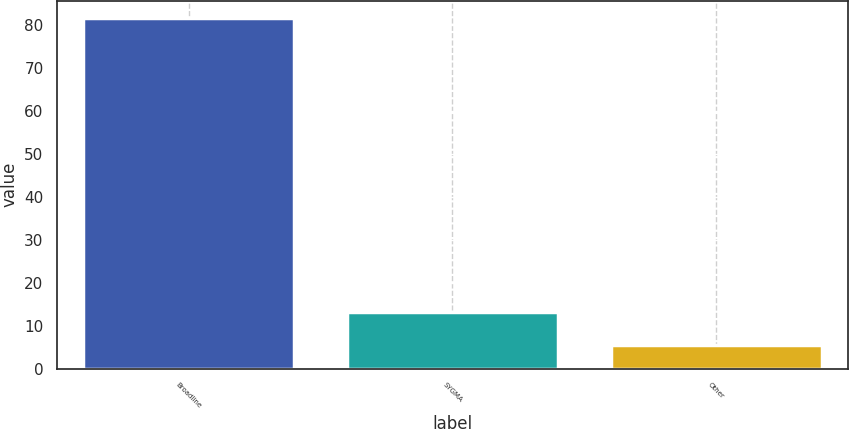Convert chart to OTSL. <chart><loc_0><loc_0><loc_500><loc_500><bar_chart><fcel>Broadline<fcel>SYGMA<fcel>Other<nl><fcel>81.6<fcel>13.2<fcel>5.6<nl></chart> 